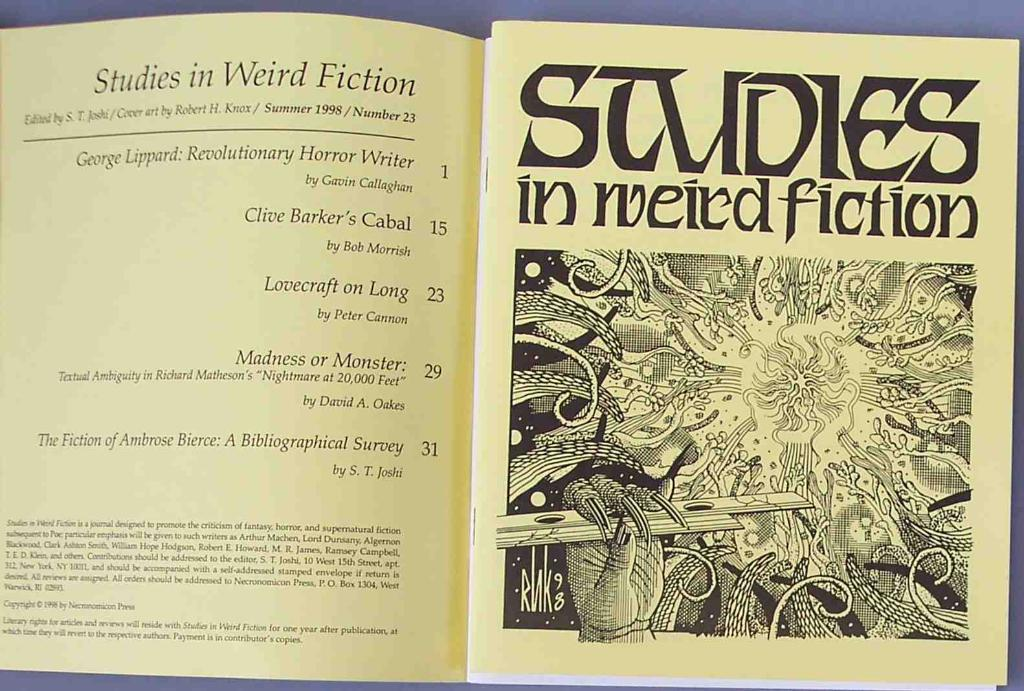What is the main object in the image? There is a book in the image. What type of content can be found in the book? The book contains text and images. What type of creature can be seen in the image? There is no creature present in the image; it only features a book with text and images. What country is depicted in the image? The image does not depict any country; it only features a book with text and images. 